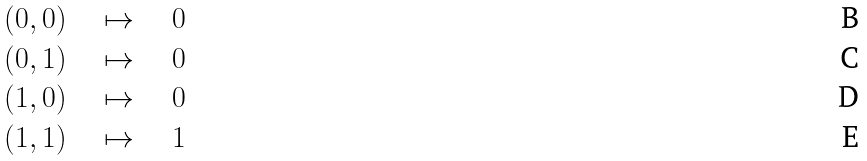<formula> <loc_0><loc_0><loc_500><loc_500>( 0 , 0 ) \quad & \mapsto \quad 0 \\ ( 0 , 1 ) \quad & \mapsto \quad 0 \\ ( 1 , 0 ) \quad & \mapsto \quad 0 \\ ( 1 , 1 ) \quad & \mapsto \quad 1</formula> 